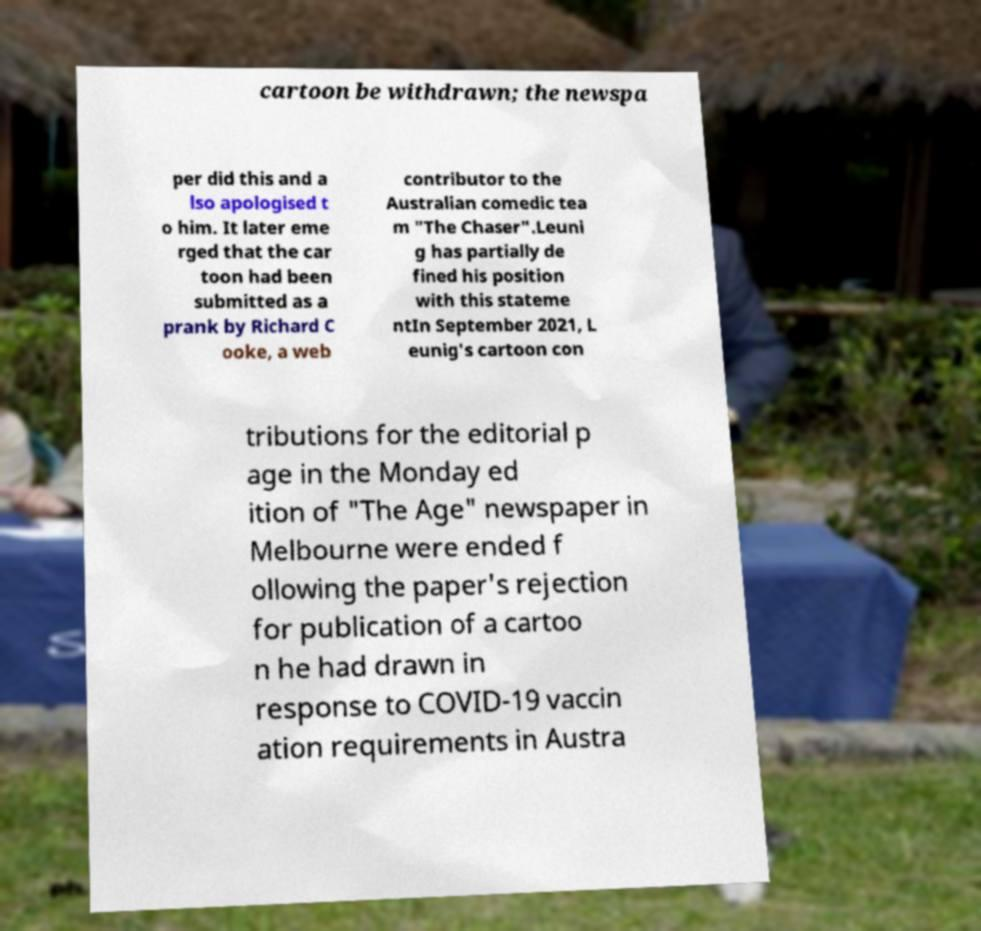For documentation purposes, I need the text within this image transcribed. Could you provide that? cartoon be withdrawn; the newspa per did this and a lso apologised t o him. It later eme rged that the car toon had been submitted as a prank by Richard C ooke, a web contributor to the Australian comedic tea m "The Chaser".Leuni g has partially de fined his position with this stateme ntIn September 2021, L eunig's cartoon con tributions for the editorial p age in the Monday ed ition of "The Age" newspaper in Melbourne were ended f ollowing the paper's rejection for publication of a cartoo n he had drawn in response to COVID-19 vaccin ation requirements in Austra 